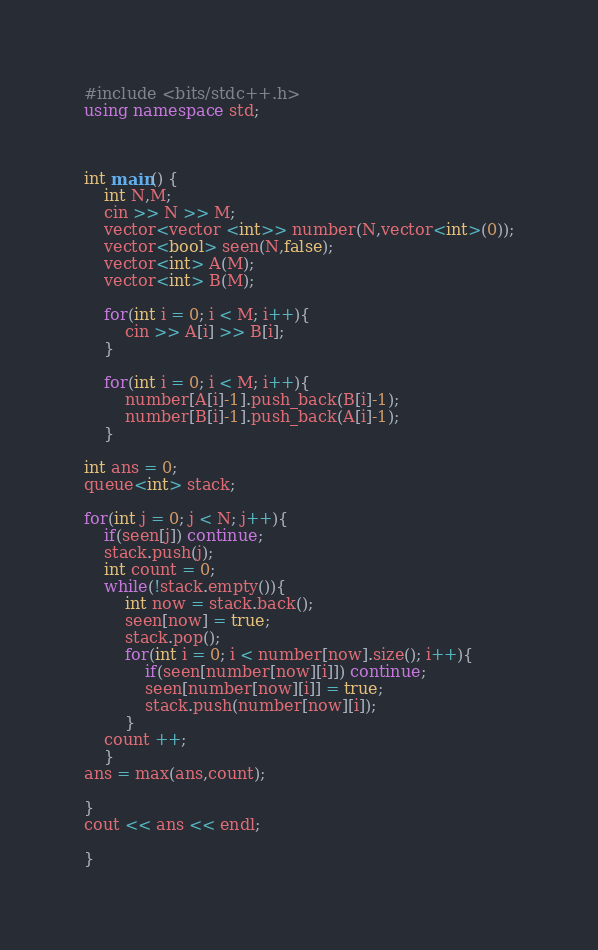<code> <loc_0><loc_0><loc_500><loc_500><_C++_>#include <bits/stdc++.h>
using namespace std;



int main() {
    int N,M;
    cin >> N >> M;
    vector<vector <int>> number(N,vector<int>(0));
    vector<bool> seen(N,false);
    vector<int> A(M);
    vector<int> B(M);

    for(int i = 0; i < M; i++){
        cin >> A[i] >> B[i];
    }

    for(int i = 0; i < M; i++){
        number[A[i]-1].push_back(B[i]-1);
        number[B[i]-1].push_back(A[i]-1);
    }

int ans = 0;
queue<int> stack;

for(int j = 0; j < N; j++){
    if(seen[j]) continue;
    stack.push(j);
    int count = 0;
    while(!stack.empty()){
        int now = stack.back();
        seen[now] = true;
        stack.pop();
        for(int i = 0; i < number[now].size(); i++){
            if(seen[number[now][i]]) continue;
            seen[number[now][i]] = true;
            stack.push(number[now][i]);
        }
    count ++;
    }
ans = max(ans,count);

}
cout << ans << endl;

}
</code> 